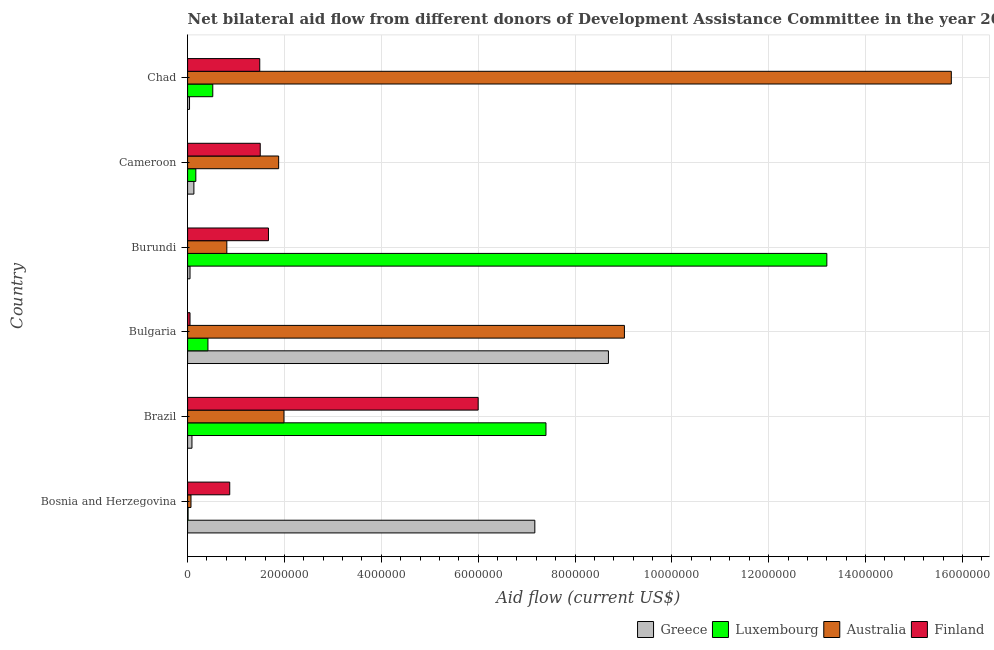How many different coloured bars are there?
Your answer should be very brief. 4. Are the number of bars per tick equal to the number of legend labels?
Offer a terse response. Yes. What is the label of the 3rd group of bars from the top?
Provide a short and direct response. Burundi. What is the amount of aid given by finland in Chad?
Provide a succinct answer. 1.49e+06. Across all countries, what is the maximum amount of aid given by australia?
Give a very brief answer. 1.58e+07. Across all countries, what is the minimum amount of aid given by australia?
Keep it short and to the point. 7.00e+04. In which country was the amount of aid given by australia maximum?
Your answer should be compact. Chad. In which country was the amount of aid given by luxembourg minimum?
Make the answer very short. Bosnia and Herzegovina. What is the total amount of aid given by finland in the graph?
Give a very brief answer. 1.16e+07. What is the difference between the amount of aid given by luxembourg in Bulgaria and that in Cameroon?
Offer a terse response. 2.50e+05. What is the difference between the amount of aid given by luxembourg in Bulgaria and the amount of aid given by australia in Bosnia and Herzegovina?
Your answer should be very brief. 3.50e+05. What is the average amount of aid given by greece per country?
Your response must be concise. 2.70e+06. What is the difference between the amount of aid given by finland and amount of aid given by australia in Cameroon?
Provide a succinct answer. -3.80e+05. In how many countries, is the amount of aid given by australia greater than 10400000 US$?
Offer a very short reply. 1. What is the ratio of the amount of aid given by luxembourg in Brazil to that in Chad?
Your answer should be compact. 14.23. Is the difference between the amount of aid given by australia in Bulgaria and Chad greater than the difference between the amount of aid given by luxembourg in Bulgaria and Chad?
Offer a very short reply. No. What is the difference between the highest and the second highest amount of aid given by greece?
Offer a very short reply. 1.52e+06. What is the difference between the highest and the lowest amount of aid given by finland?
Offer a terse response. 5.95e+06. In how many countries, is the amount of aid given by luxembourg greater than the average amount of aid given by luxembourg taken over all countries?
Ensure brevity in your answer.  2. Is it the case that in every country, the sum of the amount of aid given by australia and amount of aid given by luxembourg is greater than the sum of amount of aid given by finland and amount of aid given by greece?
Make the answer very short. No. What does the 2nd bar from the top in Burundi represents?
Offer a very short reply. Australia. Is it the case that in every country, the sum of the amount of aid given by greece and amount of aid given by luxembourg is greater than the amount of aid given by australia?
Your response must be concise. No. How many bars are there?
Keep it short and to the point. 24. Are all the bars in the graph horizontal?
Offer a very short reply. Yes. How many countries are there in the graph?
Ensure brevity in your answer.  6. Where does the legend appear in the graph?
Your answer should be compact. Bottom right. How many legend labels are there?
Your answer should be compact. 4. What is the title of the graph?
Give a very brief answer. Net bilateral aid flow from different donors of Development Assistance Committee in the year 2004. Does "Periodicity assessment" appear as one of the legend labels in the graph?
Give a very brief answer. No. What is the label or title of the X-axis?
Give a very brief answer. Aid flow (current US$). What is the label or title of the Y-axis?
Provide a succinct answer. Country. What is the Aid flow (current US$) in Greece in Bosnia and Herzegovina?
Your response must be concise. 7.17e+06. What is the Aid flow (current US$) of Luxembourg in Bosnia and Herzegovina?
Offer a very short reply. 10000. What is the Aid flow (current US$) of Finland in Bosnia and Herzegovina?
Your response must be concise. 8.70e+05. What is the Aid flow (current US$) in Greece in Brazil?
Provide a short and direct response. 9.00e+04. What is the Aid flow (current US$) in Luxembourg in Brazil?
Your answer should be very brief. 7.40e+06. What is the Aid flow (current US$) of Australia in Brazil?
Provide a succinct answer. 1.99e+06. What is the Aid flow (current US$) of Finland in Brazil?
Make the answer very short. 6.00e+06. What is the Aid flow (current US$) of Greece in Bulgaria?
Provide a succinct answer. 8.69e+06. What is the Aid flow (current US$) in Australia in Bulgaria?
Ensure brevity in your answer.  9.02e+06. What is the Aid flow (current US$) of Finland in Bulgaria?
Keep it short and to the point. 5.00e+04. What is the Aid flow (current US$) in Greece in Burundi?
Provide a short and direct response. 5.00e+04. What is the Aid flow (current US$) of Luxembourg in Burundi?
Offer a very short reply. 1.32e+07. What is the Aid flow (current US$) in Australia in Burundi?
Keep it short and to the point. 8.10e+05. What is the Aid flow (current US$) of Finland in Burundi?
Keep it short and to the point. 1.67e+06. What is the Aid flow (current US$) of Greece in Cameroon?
Keep it short and to the point. 1.30e+05. What is the Aid flow (current US$) of Australia in Cameroon?
Provide a short and direct response. 1.88e+06. What is the Aid flow (current US$) in Finland in Cameroon?
Provide a short and direct response. 1.50e+06. What is the Aid flow (current US$) in Greece in Chad?
Provide a short and direct response. 4.00e+04. What is the Aid flow (current US$) of Luxembourg in Chad?
Make the answer very short. 5.20e+05. What is the Aid flow (current US$) of Australia in Chad?
Make the answer very short. 1.58e+07. What is the Aid flow (current US$) in Finland in Chad?
Offer a terse response. 1.49e+06. Across all countries, what is the maximum Aid flow (current US$) in Greece?
Your response must be concise. 8.69e+06. Across all countries, what is the maximum Aid flow (current US$) in Luxembourg?
Ensure brevity in your answer.  1.32e+07. Across all countries, what is the maximum Aid flow (current US$) in Australia?
Keep it short and to the point. 1.58e+07. Across all countries, what is the maximum Aid flow (current US$) of Finland?
Keep it short and to the point. 6.00e+06. Across all countries, what is the minimum Aid flow (current US$) of Greece?
Offer a terse response. 4.00e+04. Across all countries, what is the minimum Aid flow (current US$) of Australia?
Make the answer very short. 7.00e+04. Across all countries, what is the minimum Aid flow (current US$) of Finland?
Provide a succinct answer. 5.00e+04. What is the total Aid flow (current US$) in Greece in the graph?
Provide a short and direct response. 1.62e+07. What is the total Aid flow (current US$) in Luxembourg in the graph?
Make the answer very short. 2.17e+07. What is the total Aid flow (current US$) in Australia in the graph?
Offer a terse response. 2.95e+07. What is the total Aid flow (current US$) in Finland in the graph?
Keep it short and to the point. 1.16e+07. What is the difference between the Aid flow (current US$) of Greece in Bosnia and Herzegovina and that in Brazil?
Offer a terse response. 7.08e+06. What is the difference between the Aid flow (current US$) in Luxembourg in Bosnia and Herzegovina and that in Brazil?
Offer a terse response. -7.39e+06. What is the difference between the Aid flow (current US$) of Australia in Bosnia and Herzegovina and that in Brazil?
Give a very brief answer. -1.92e+06. What is the difference between the Aid flow (current US$) of Finland in Bosnia and Herzegovina and that in Brazil?
Keep it short and to the point. -5.13e+06. What is the difference between the Aid flow (current US$) of Greece in Bosnia and Herzegovina and that in Bulgaria?
Your answer should be very brief. -1.52e+06. What is the difference between the Aid flow (current US$) of Luxembourg in Bosnia and Herzegovina and that in Bulgaria?
Offer a terse response. -4.10e+05. What is the difference between the Aid flow (current US$) of Australia in Bosnia and Herzegovina and that in Bulgaria?
Ensure brevity in your answer.  -8.95e+06. What is the difference between the Aid flow (current US$) in Finland in Bosnia and Herzegovina and that in Bulgaria?
Your answer should be compact. 8.20e+05. What is the difference between the Aid flow (current US$) of Greece in Bosnia and Herzegovina and that in Burundi?
Your answer should be very brief. 7.12e+06. What is the difference between the Aid flow (current US$) in Luxembourg in Bosnia and Herzegovina and that in Burundi?
Provide a short and direct response. -1.32e+07. What is the difference between the Aid flow (current US$) in Australia in Bosnia and Herzegovina and that in Burundi?
Your response must be concise. -7.40e+05. What is the difference between the Aid flow (current US$) of Finland in Bosnia and Herzegovina and that in Burundi?
Your answer should be very brief. -8.00e+05. What is the difference between the Aid flow (current US$) in Greece in Bosnia and Herzegovina and that in Cameroon?
Make the answer very short. 7.04e+06. What is the difference between the Aid flow (current US$) in Australia in Bosnia and Herzegovina and that in Cameroon?
Offer a very short reply. -1.81e+06. What is the difference between the Aid flow (current US$) of Finland in Bosnia and Herzegovina and that in Cameroon?
Ensure brevity in your answer.  -6.30e+05. What is the difference between the Aid flow (current US$) in Greece in Bosnia and Herzegovina and that in Chad?
Give a very brief answer. 7.13e+06. What is the difference between the Aid flow (current US$) in Luxembourg in Bosnia and Herzegovina and that in Chad?
Give a very brief answer. -5.10e+05. What is the difference between the Aid flow (current US$) in Australia in Bosnia and Herzegovina and that in Chad?
Give a very brief answer. -1.57e+07. What is the difference between the Aid flow (current US$) in Finland in Bosnia and Herzegovina and that in Chad?
Your response must be concise. -6.20e+05. What is the difference between the Aid flow (current US$) of Greece in Brazil and that in Bulgaria?
Provide a succinct answer. -8.60e+06. What is the difference between the Aid flow (current US$) in Luxembourg in Brazil and that in Bulgaria?
Give a very brief answer. 6.98e+06. What is the difference between the Aid flow (current US$) in Australia in Brazil and that in Bulgaria?
Your answer should be very brief. -7.03e+06. What is the difference between the Aid flow (current US$) in Finland in Brazil and that in Bulgaria?
Offer a very short reply. 5.95e+06. What is the difference between the Aid flow (current US$) of Luxembourg in Brazil and that in Burundi?
Keep it short and to the point. -5.80e+06. What is the difference between the Aid flow (current US$) in Australia in Brazil and that in Burundi?
Your answer should be compact. 1.18e+06. What is the difference between the Aid flow (current US$) in Finland in Brazil and that in Burundi?
Offer a terse response. 4.33e+06. What is the difference between the Aid flow (current US$) of Luxembourg in Brazil and that in Cameroon?
Provide a short and direct response. 7.23e+06. What is the difference between the Aid flow (current US$) of Finland in Brazil and that in Cameroon?
Make the answer very short. 4.50e+06. What is the difference between the Aid flow (current US$) of Greece in Brazil and that in Chad?
Give a very brief answer. 5.00e+04. What is the difference between the Aid flow (current US$) in Luxembourg in Brazil and that in Chad?
Provide a succinct answer. 6.88e+06. What is the difference between the Aid flow (current US$) in Australia in Brazil and that in Chad?
Provide a short and direct response. -1.38e+07. What is the difference between the Aid flow (current US$) of Finland in Brazil and that in Chad?
Your response must be concise. 4.51e+06. What is the difference between the Aid flow (current US$) in Greece in Bulgaria and that in Burundi?
Ensure brevity in your answer.  8.64e+06. What is the difference between the Aid flow (current US$) of Luxembourg in Bulgaria and that in Burundi?
Offer a terse response. -1.28e+07. What is the difference between the Aid flow (current US$) in Australia in Bulgaria and that in Burundi?
Give a very brief answer. 8.21e+06. What is the difference between the Aid flow (current US$) in Finland in Bulgaria and that in Burundi?
Your answer should be very brief. -1.62e+06. What is the difference between the Aid flow (current US$) in Greece in Bulgaria and that in Cameroon?
Your answer should be very brief. 8.56e+06. What is the difference between the Aid flow (current US$) in Australia in Bulgaria and that in Cameroon?
Offer a very short reply. 7.14e+06. What is the difference between the Aid flow (current US$) of Finland in Bulgaria and that in Cameroon?
Provide a short and direct response. -1.45e+06. What is the difference between the Aid flow (current US$) of Greece in Bulgaria and that in Chad?
Your answer should be compact. 8.65e+06. What is the difference between the Aid flow (current US$) of Luxembourg in Bulgaria and that in Chad?
Your response must be concise. -1.00e+05. What is the difference between the Aid flow (current US$) in Australia in Bulgaria and that in Chad?
Offer a terse response. -6.75e+06. What is the difference between the Aid flow (current US$) of Finland in Bulgaria and that in Chad?
Offer a very short reply. -1.44e+06. What is the difference between the Aid flow (current US$) in Luxembourg in Burundi and that in Cameroon?
Ensure brevity in your answer.  1.30e+07. What is the difference between the Aid flow (current US$) of Australia in Burundi and that in Cameroon?
Ensure brevity in your answer.  -1.07e+06. What is the difference between the Aid flow (current US$) of Greece in Burundi and that in Chad?
Your answer should be very brief. 10000. What is the difference between the Aid flow (current US$) of Luxembourg in Burundi and that in Chad?
Make the answer very short. 1.27e+07. What is the difference between the Aid flow (current US$) of Australia in Burundi and that in Chad?
Provide a short and direct response. -1.50e+07. What is the difference between the Aid flow (current US$) in Finland in Burundi and that in Chad?
Give a very brief answer. 1.80e+05. What is the difference between the Aid flow (current US$) in Greece in Cameroon and that in Chad?
Your response must be concise. 9.00e+04. What is the difference between the Aid flow (current US$) of Luxembourg in Cameroon and that in Chad?
Your answer should be compact. -3.50e+05. What is the difference between the Aid flow (current US$) of Australia in Cameroon and that in Chad?
Give a very brief answer. -1.39e+07. What is the difference between the Aid flow (current US$) in Greece in Bosnia and Herzegovina and the Aid flow (current US$) in Australia in Brazil?
Offer a very short reply. 5.18e+06. What is the difference between the Aid flow (current US$) in Greece in Bosnia and Herzegovina and the Aid flow (current US$) in Finland in Brazil?
Give a very brief answer. 1.17e+06. What is the difference between the Aid flow (current US$) in Luxembourg in Bosnia and Herzegovina and the Aid flow (current US$) in Australia in Brazil?
Your answer should be very brief. -1.98e+06. What is the difference between the Aid flow (current US$) of Luxembourg in Bosnia and Herzegovina and the Aid flow (current US$) of Finland in Brazil?
Keep it short and to the point. -5.99e+06. What is the difference between the Aid flow (current US$) of Australia in Bosnia and Herzegovina and the Aid flow (current US$) of Finland in Brazil?
Your answer should be very brief. -5.93e+06. What is the difference between the Aid flow (current US$) in Greece in Bosnia and Herzegovina and the Aid flow (current US$) in Luxembourg in Bulgaria?
Keep it short and to the point. 6.75e+06. What is the difference between the Aid flow (current US$) of Greece in Bosnia and Herzegovina and the Aid flow (current US$) of Australia in Bulgaria?
Provide a succinct answer. -1.85e+06. What is the difference between the Aid flow (current US$) of Greece in Bosnia and Herzegovina and the Aid flow (current US$) of Finland in Bulgaria?
Ensure brevity in your answer.  7.12e+06. What is the difference between the Aid flow (current US$) in Luxembourg in Bosnia and Herzegovina and the Aid flow (current US$) in Australia in Bulgaria?
Your response must be concise. -9.01e+06. What is the difference between the Aid flow (current US$) in Australia in Bosnia and Herzegovina and the Aid flow (current US$) in Finland in Bulgaria?
Provide a succinct answer. 2.00e+04. What is the difference between the Aid flow (current US$) of Greece in Bosnia and Herzegovina and the Aid flow (current US$) of Luxembourg in Burundi?
Provide a short and direct response. -6.03e+06. What is the difference between the Aid flow (current US$) in Greece in Bosnia and Herzegovina and the Aid flow (current US$) in Australia in Burundi?
Your response must be concise. 6.36e+06. What is the difference between the Aid flow (current US$) of Greece in Bosnia and Herzegovina and the Aid flow (current US$) of Finland in Burundi?
Keep it short and to the point. 5.50e+06. What is the difference between the Aid flow (current US$) of Luxembourg in Bosnia and Herzegovina and the Aid flow (current US$) of Australia in Burundi?
Make the answer very short. -8.00e+05. What is the difference between the Aid flow (current US$) in Luxembourg in Bosnia and Herzegovina and the Aid flow (current US$) in Finland in Burundi?
Your answer should be compact. -1.66e+06. What is the difference between the Aid flow (current US$) in Australia in Bosnia and Herzegovina and the Aid flow (current US$) in Finland in Burundi?
Your answer should be compact. -1.60e+06. What is the difference between the Aid flow (current US$) of Greece in Bosnia and Herzegovina and the Aid flow (current US$) of Luxembourg in Cameroon?
Provide a succinct answer. 7.00e+06. What is the difference between the Aid flow (current US$) of Greece in Bosnia and Herzegovina and the Aid flow (current US$) of Australia in Cameroon?
Offer a terse response. 5.29e+06. What is the difference between the Aid flow (current US$) of Greece in Bosnia and Herzegovina and the Aid flow (current US$) of Finland in Cameroon?
Offer a terse response. 5.67e+06. What is the difference between the Aid flow (current US$) in Luxembourg in Bosnia and Herzegovina and the Aid flow (current US$) in Australia in Cameroon?
Give a very brief answer. -1.87e+06. What is the difference between the Aid flow (current US$) in Luxembourg in Bosnia and Herzegovina and the Aid flow (current US$) in Finland in Cameroon?
Your response must be concise. -1.49e+06. What is the difference between the Aid flow (current US$) of Australia in Bosnia and Herzegovina and the Aid flow (current US$) of Finland in Cameroon?
Offer a terse response. -1.43e+06. What is the difference between the Aid flow (current US$) in Greece in Bosnia and Herzegovina and the Aid flow (current US$) in Luxembourg in Chad?
Provide a succinct answer. 6.65e+06. What is the difference between the Aid flow (current US$) in Greece in Bosnia and Herzegovina and the Aid flow (current US$) in Australia in Chad?
Offer a very short reply. -8.60e+06. What is the difference between the Aid flow (current US$) of Greece in Bosnia and Herzegovina and the Aid flow (current US$) of Finland in Chad?
Your answer should be very brief. 5.68e+06. What is the difference between the Aid flow (current US$) of Luxembourg in Bosnia and Herzegovina and the Aid flow (current US$) of Australia in Chad?
Offer a terse response. -1.58e+07. What is the difference between the Aid flow (current US$) in Luxembourg in Bosnia and Herzegovina and the Aid flow (current US$) in Finland in Chad?
Your answer should be very brief. -1.48e+06. What is the difference between the Aid flow (current US$) of Australia in Bosnia and Herzegovina and the Aid flow (current US$) of Finland in Chad?
Your response must be concise. -1.42e+06. What is the difference between the Aid flow (current US$) of Greece in Brazil and the Aid flow (current US$) of Luxembourg in Bulgaria?
Offer a very short reply. -3.30e+05. What is the difference between the Aid flow (current US$) of Greece in Brazil and the Aid flow (current US$) of Australia in Bulgaria?
Offer a very short reply. -8.93e+06. What is the difference between the Aid flow (current US$) in Greece in Brazil and the Aid flow (current US$) in Finland in Bulgaria?
Your response must be concise. 4.00e+04. What is the difference between the Aid flow (current US$) in Luxembourg in Brazil and the Aid flow (current US$) in Australia in Bulgaria?
Give a very brief answer. -1.62e+06. What is the difference between the Aid flow (current US$) of Luxembourg in Brazil and the Aid flow (current US$) of Finland in Bulgaria?
Ensure brevity in your answer.  7.35e+06. What is the difference between the Aid flow (current US$) in Australia in Brazil and the Aid flow (current US$) in Finland in Bulgaria?
Offer a very short reply. 1.94e+06. What is the difference between the Aid flow (current US$) in Greece in Brazil and the Aid flow (current US$) in Luxembourg in Burundi?
Provide a succinct answer. -1.31e+07. What is the difference between the Aid flow (current US$) of Greece in Brazil and the Aid flow (current US$) of Australia in Burundi?
Keep it short and to the point. -7.20e+05. What is the difference between the Aid flow (current US$) of Greece in Brazil and the Aid flow (current US$) of Finland in Burundi?
Keep it short and to the point. -1.58e+06. What is the difference between the Aid flow (current US$) in Luxembourg in Brazil and the Aid flow (current US$) in Australia in Burundi?
Make the answer very short. 6.59e+06. What is the difference between the Aid flow (current US$) of Luxembourg in Brazil and the Aid flow (current US$) of Finland in Burundi?
Ensure brevity in your answer.  5.73e+06. What is the difference between the Aid flow (current US$) in Australia in Brazil and the Aid flow (current US$) in Finland in Burundi?
Your answer should be very brief. 3.20e+05. What is the difference between the Aid flow (current US$) of Greece in Brazil and the Aid flow (current US$) of Australia in Cameroon?
Offer a terse response. -1.79e+06. What is the difference between the Aid flow (current US$) in Greece in Brazil and the Aid flow (current US$) in Finland in Cameroon?
Your answer should be compact. -1.41e+06. What is the difference between the Aid flow (current US$) of Luxembourg in Brazil and the Aid flow (current US$) of Australia in Cameroon?
Ensure brevity in your answer.  5.52e+06. What is the difference between the Aid flow (current US$) in Luxembourg in Brazil and the Aid flow (current US$) in Finland in Cameroon?
Ensure brevity in your answer.  5.90e+06. What is the difference between the Aid flow (current US$) of Greece in Brazil and the Aid flow (current US$) of Luxembourg in Chad?
Provide a short and direct response. -4.30e+05. What is the difference between the Aid flow (current US$) in Greece in Brazil and the Aid flow (current US$) in Australia in Chad?
Offer a very short reply. -1.57e+07. What is the difference between the Aid flow (current US$) of Greece in Brazil and the Aid flow (current US$) of Finland in Chad?
Provide a succinct answer. -1.40e+06. What is the difference between the Aid flow (current US$) in Luxembourg in Brazil and the Aid flow (current US$) in Australia in Chad?
Keep it short and to the point. -8.37e+06. What is the difference between the Aid flow (current US$) in Luxembourg in Brazil and the Aid flow (current US$) in Finland in Chad?
Offer a terse response. 5.91e+06. What is the difference between the Aid flow (current US$) in Greece in Bulgaria and the Aid flow (current US$) in Luxembourg in Burundi?
Your answer should be compact. -4.51e+06. What is the difference between the Aid flow (current US$) of Greece in Bulgaria and the Aid flow (current US$) of Australia in Burundi?
Your answer should be very brief. 7.88e+06. What is the difference between the Aid flow (current US$) of Greece in Bulgaria and the Aid flow (current US$) of Finland in Burundi?
Your answer should be very brief. 7.02e+06. What is the difference between the Aid flow (current US$) of Luxembourg in Bulgaria and the Aid flow (current US$) of Australia in Burundi?
Ensure brevity in your answer.  -3.90e+05. What is the difference between the Aid flow (current US$) in Luxembourg in Bulgaria and the Aid flow (current US$) in Finland in Burundi?
Your answer should be compact. -1.25e+06. What is the difference between the Aid flow (current US$) in Australia in Bulgaria and the Aid flow (current US$) in Finland in Burundi?
Your response must be concise. 7.35e+06. What is the difference between the Aid flow (current US$) of Greece in Bulgaria and the Aid flow (current US$) of Luxembourg in Cameroon?
Your response must be concise. 8.52e+06. What is the difference between the Aid flow (current US$) in Greece in Bulgaria and the Aid flow (current US$) in Australia in Cameroon?
Keep it short and to the point. 6.81e+06. What is the difference between the Aid flow (current US$) in Greece in Bulgaria and the Aid flow (current US$) in Finland in Cameroon?
Provide a short and direct response. 7.19e+06. What is the difference between the Aid flow (current US$) of Luxembourg in Bulgaria and the Aid flow (current US$) of Australia in Cameroon?
Your answer should be compact. -1.46e+06. What is the difference between the Aid flow (current US$) in Luxembourg in Bulgaria and the Aid flow (current US$) in Finland in Cameroon?
Make the answer very short. -1.08e+06. What is the difference between the Aid flow (current US$) of Australia in Bulgaria and the Aid flow (current US$) of Finland in Cameroon?
Provide a short and direct response. 7.52e+06. What is the difference between the Aid flow (current US$) in Greece in Bulgaria and the Aid flow (current US$) in Luxembourg in Chad?
Give a very brief answer. 8.17e+06. What is the difference between the Aid flow (current US$) of Greece in Bulgaria and the Aid flow (current US$) of Australia in Chad?
Make the answer very short. -7.08e+06. What is the difference between the Aid flow (current US$) in Greece in Bulgaria and the Aid flow (current US$) in Finland in Chad?
Make the answer very short. 7.20e+06. What is the difference between the Aid flow (current US$) in Luxembourg in Bulgaria and the Aid flow (current US$) in Australia in Chad?
Offer a terse response. -1.54e+07. What is the difference between the Aid flow (current US$) of Luxembourg in Bulgaria and the Aid flow (current US$) of Finland in Chad?
Give a very brief answer. -1.07e+06. What is the difference between the Aid flow (current US$) of Australia in Bulgaria and the Aid flow (current US$) of Finland in Chad?
Keep it short and to the point. 7.53e+06. What is the difference between the Aid flow (current US$) in Greece in Burundi and the Aid flow (current US$) in Luxembourg in Cameroon?
Make the answer very short. -1.20e+05. What is the difference between the Aid flow (current US$) in Greece in Burundi and the Aid flow (current US$) in Australia in Cameroon?
Offer a terse response. -1.83e+06. What is the difference between the Aid flow (current US$) in Greece in Burundi and the Aid flow (current US$) in Finland in Cameroon?
Give a very brief answer. -1.45e+06. What is the difference between the Aid flow (current US$) of Luxembourg in Burundi and the Aid flow (current US$) of Australia in Cameroon?
Offer a very short reply. 1.13e+07. What is the difference between the Aid flow (current US$) of Luxembourg in Burundi and the Aid flow (current US$) of Finland in Cameroon?
Ensure brevity in your answer.  1.17e+07. What is the difference between the Aid flow (current US$) of Australia in Burundi and the Aid flow (current US$) of Finland in Cameroon?
Offer a very short reply. -6.90e+05. What is the difference between the Aid flow (current US$) of Greece in Burundi and the Aid flow (current US$) of Luxembourg in Chad?
Your response must be concise. -4.70e+05. What is the difference between the Aid flow (current US$) in Greece in Burundi and the Aid flow (current US$) in Australia in Chad?
Give a very brief answer. -1.57e+07. What is the difference between the Aid flow (current US$) in Greece in Burundi and the Aid flow (current US$) in Finland in Chad?
Ensure brevity in your answer.  -1.44e+06. What is the difference between the Aid flow (current US$) of Luxembourg in Burundi and the Aid flow (current US$) of Australia in Chad?
Give a very brief answer. -2.57e+06. What is the difference between the Aid flow (current US$) in Luxembourg in Burundi and the Aid flow (current US$) in Finland in Chad?
Provide a short and direct response. 1.17e+07. What is the difference between the Aid flow (current US$) in Australia in Burundi and the Aid flow (current US$) in Finland in Chad?
Your answer should be very brief. -6.80e+05. What is the difference between the Aid flow (current US$) of Greece in Cameroon and the Aid flow (current US$) of Luxembourg in Chad?
Your response must be concise. -3.90e+05. What is the difference between the Aid flow (current US$) in Greece in Cameroon and the Aid flow (current US$) in Australia in Chad?
Your answer should be very brief. -1.56e+07. What is the difference between the Aid flow (current US$) of Greece in Cameroon and the Aid flow (current US$) of Finland in Chad?
Give a very brief answer. -1.36e+06. What is the difference between the Aid flow (current US$) in Luxembourg in Cameroon and the Aid flow (current US$) in Australia in Chad?
Provide a short and direct response. -1.56e+07. What is the difference between the Aid flow (current US$) in Luxembourg in Cameroon and the Aid flow (current US$) in Finland in Chad?
Give a very brief answer. -1.32e+06. What is the difference between the Aid flow (current US$) of Australia in Cameroon and the Aid flow (current US$) of Finland in Chad?
Keep it short and to the point. 3.90e+05. What is the average Aid flow (current US$) in Greece per country?
Provide a succinct answer. 2.70e+06. What is the average Aid flow (current US$) in Luxembourg per country?
Offer a terse response. 3.62e+06. What is the average Aid flow (current US$) in Australia per country?
Give a very brief answer. 4.92e+06. What is the average Aid flow (current US$) in Finland per country?
Your response must be concise. 1.93e+06. What is the difference between the Aid flow (current US$) in Greece and Aid flow (current US$) in Luxembourg in Bosnia and Herzegovina?
Keep it short and to the point. 7.16e+06. What is the difference between the Aid flow (current US$) of Greece and Aid flow (current US$) of Australia in Bosnia and Herzegovina?
Offer a very short reply. 7.10e+06. What is the difference between the Aid flow (current US$) in Greece and Aid flow (current US$) in Finland in Bosnia and Herzegovina?
Your response must be concise. 6.30e+06. What is the difference between the Aid flow (current US$) of Luxembourg and Aid flow (current US$) of Australia in Bosnia and Herzegovina?
Offer a very short reply. -6.00e+04. What is the difference between the Aid flow (current US$) in Luxembourg and Aid flow (current US$) in Finland in Bosnia and Herzegovina?
Provide a succinct answer. -8.60e+05. What is the difference between the Aid flow (current US$) in Australia and Aid flow (current US$) in Finland in Bosnia and Herzegovina?
Give a very brief answer. -8.00e+05. What is the difference between the Aid flow (current US$) in Greece and Aid flow (current US$) in Luxembourg in Brazil?
Offer a very short reply. -7.31e+06. What is the difference between the Aid flow (current US$) of Greece and Aid flow (current US$) of Australia in Brazil?
Your answer should be compact. -1.90e+06. What is the difference between the Aid flow (current US$) in Greece and Aid flow (current US$) in Finland in Brazil?
Keep it short and to the point. -5.91e+06. What is the difference between the Aid flow (current US$) of Luxembourg and Aid flow (current US$) of Australia in Brazil?
Your answer should be compact. 5.41e+06. What is the difference between the Aid flow (current US$) of Luxembourg and Aid flow (current US$) of Finland in Brazil?
Your answer should be compact. 1.40e+06. What is the difference between the Aid flow (current US$) of Australia and Aid flow (current US$) of Finland in Brazil?
Keep it short and to the point. -4.01e+06. What is the difference between the Aid flow (current US$) in Greece and Aid flow (current US$) in Luxembourg in Bulgaria?
Offer a very short reply. 8.27e+06. What is the difference between the Aid flow (current US$) of Greece and Aid flow (current US$) of Australia in Bulgaria?
Your response must be concise. -3.30e+05. What is the difference between the Aid flow (current US$) of Greece and Aid flow (current US$) of Finland in Bulgaria?
Provide a short and direct response. 8.64e+06. What is the difference between the Aid flow (current US$) of Luxembourg and Aid flow (current US$) of Australia in Bulgaria?
Provide a short and direct response. -8.60e+06. What is the difference between the Aid flow (current US$) in Luxembourg and Aid flow (current US$) in Finland in Bulgaria?
Your answer should be compact. 3.70e+05. What is the difference between the Aid flow (current US$) of Australia and Aid flow (current US$) of Finland in Bulgaria?
Your answer should be very brief. 8.97e+06. What is the difference between the Aid flow (current US$) of Greece and Aid flow (current US$) of Luxembourg in Burundi?
Make the answer very short. -1.32e+07. What is the difference between the Aid flow (current US$) of Greece and Aid flow (current US$) of Australia in Burundi?
Offer a very short reply. -7.60e+05. What is the difference between the Aid flow (current US$) in Greece and Aid flow (current US$) in Finland in Burundi?
Offer a terse response. -1.62e+06. What is the difference between the Aid flow (current US$) of Luxembourg and Aid flow (current US$) of Australia in Burundi?
Offer a terse response. 1.24e+07. What is the difference between the Aid flow (current US$) in Luxembourg and Aid flow (current US$) in Finland in Burundi?
Offer a very short reply. 1.15e+07. What is the difference between the Aid flow (current US$) in Australia and Aid flow (current US$) in Finland in Burundi?
Make the answer very short. -8.60e+05. What is the difference between the Aid flow (current US$) of Greece and Aid flow (current US$) of Luxembourg in Cameroon?
Provide a succinct answer. -4.00e+04. What is the difference between the Aid flow (current US$) in Greece and Aid flow (current US$) in Australia in Cameroon?
Your answer should be compact. -1.75e+06. What is the difference between the Aid flow (current US$) in Greece and Aid flow (current US$) in Finland in Cameroon?
Provide a short and direct response. -1.37e+06. What is the difference between the Aid flow (current US$) in Luxembourg and Aid flow (current US$) in Australia in Cameroon?
Offer a very short reply. -1.71e+06. What is the difference between the Aid flow (current US$) in Luxembourg and Aid flow (current US$) in Finland in Cameroon?
Provide a succinct answer. -1.33e+06. What is the difference between the Aid flow (current US$) of Greece and Aid flow (current US$) of Luxembourg in Chad?
Offer a terse response. -4.80e+05. What is the difference between the Aid flow (current US$) of Greece and Aid flow (current US$) of Australia in Chad?
Your answer should be compact. -1.57e+07. What is the difference between the Aid flow (current US$) of Greece and Aid flow (current US$) of Finland in Chad?
Provide a succinct answer. -1.45e+06. What is the difference between the Aid flow (current US$) in Luxembourg and Aid flow (current US$) in Australia in Chad?
Offer a very short reply. -1.52e+07. What is the difference between the Aid flow (current US$) of Luxembourg and Aid flow (current US$) of Finland in Chad?
Ensure brevity in your answer.  -9.70e+05. What is the difference between the Aid flow (current US$) of Australia and Aid flow (current US$) of Finland in Chad?
Your response must be concise. 1.43e+07. What is the ratio of the Aid flow (current US$) of Greece in Bosnia and Herzegovina to that in Brazil?
Ensure brevity in your answer.  79.67. What is the ratio of the Aid flow (current US$) of Luxembourg in Bosnia and Herzegovina to that in Brazil?
Give a very brief answer. 0. What is the ratio of the Aid flow (current US$) in Australia in Bosnia and Herzegovina to that in Brazil?
Make the answer very short. 0.04. What is the ratio of the Aid flow (current US$) in Finland in Bosnia and Herzegovina to that in Brazil?
Offer a very short reply. 0.14. What is the ratio of the Aid flow (current US$) of Greece in Bosnia and Herzegovina to that in Bulgaria?
Give a very brief answer. 0.83. What is the ratio of the Aid flow (current US$) of Luxembourg in Bosnia and Herzegovina to that in Bulgaria?
Make the answer very short. 0.02. What is the ratio of the Aid flow (current US$) in Australia in Bosnia and Herzegovina to that in Bulgaria?
Provide a short and direct response. 0.01. What is the ratio of the Aid flow (current US$) in Finland in Bosnia and Herzegovina to that in Bulgaria?
Offer a very short reply. 17.4. What is the ratio of the Aid flow (current US$) of Greece in Bosnia and Herzegovina to that in Burundi?
Offer a very short reply. 143.4. What is the ratio of the Aid flow (current US$) in Luxembourg in Bosnia and Herzegovina to that in Burundi?
Ensure brevity in your answer.  0. What is the ratio of the Aid flow (current US$) in Australia in Bosnia and Herzegovina to that in Burundi?
Offer a very short reply. 0.09. What is the ratio of the Aid flow (current US$) of Finland in Bosnia and Herzegovina to that in Burundi?
Ensure brevity in your answer.  0.52. What is the ratio of the Aid flow (current US$) in Greece in Bosnia and Herzegovina to that in Cameroon?
Make the answer very short. 55.15. What is the ratio of the Aid flow (current US$) of Luxembourg in Bosnia and Herzegovina to that in Cameroon?
Ensure brevity in your answer.  0.06. What is the ratio of the Aid flow (current US$) in Australia in Bosnia and Herzegovina to that in Cameroon?
Your answer should be compact. 0.04. What is the ratio of the Aid flow (current US$) of Finland in Bosnia and Herzegovina to that in Cameroon?
Provide a succinct answer. 0.58. What is the ratio of the Aid flow (current US$) of Greece in Bosnia and Herzegovina to that in Chad?
Give a very brief answer. 179.25. What is the ratio of the Aid flow (current US$) of Luxembourg in Bosnia and Herzegovina to that in Chad?
Offer a terse response. 0.02. What is the ratio of the Aid flow (current US$) of Australia in Bosnia and Herzegovina to that in Chad?
Ensure brevity in your answer.  0. What is the ratio of the Aid flow (current US$) in Finland in Bosnia and Herzegovina to that in Chad?
Make the answer very short. 0.58. What is the ratio of the Aid flow (current US$) in Greece in Brazil to that in Bulgaria?
Give a very brief answer. 0.01. What is the ratio of the Aid flow (current US$) of Luxembourg in Brazil to that in Bulgaria?
Your answer should be very brief. 17.62. What is the ratio of the Aid flow (current US$) of Australia in Brazil to that in Bulgaria?
Provide a succinct answer. 0.22. What is the ratio of the Aid flow (current US$) in Finland in Brazil to that in Bulgaria?
Make the answer very short. 120. What is the ratio of the Aid flow (current US$) of Greece in Brazil to that in Burundi?
Your response must be concise. 1.8. What is the ratio of the Aid flow (current US$) of Luxembourg in Brazil to that in Burundi?
Offer a very short reply. 0.56. What is the ratio of the Aid flow (current US$) of Australia in Brazil to that in Burundi?
Provide a succinct answer. 2.46. What is the ratio of the Aid flow (current US$) in Finland in Brazil to that in Burundi?
Your answer should be compact. 3.59. What is the ratio of the Aid flow (current US$) in Greece in Brazil to that in Cameroon?
Your answer should be very brief. 0.69. What is the ratio of the Aid flow (current US$) in Luxembourg in Brazil to that in Cameroon?
Your answer should be very brief. 43.53. What is the ratio of the Aid flow (current US$) of Australia in Brazil to that in Cameroon?
Make the answer very short. 1.06. What is the ratio of the Aid flow (current US$) in Greece in Brazil to that in Chad?
Provide a succinct answer. 2.25. What is the ratio of the Aid flow (current US$) of Luxembourg in Brazil to that in Chad?
Your answer should be compact. 14.23. What is the ratio of the Aid flow (current US$) in Australia in Brazil to that in Chad?
Provide a short and direct response. 0.13. What is the ratio of the Aid flow (current US$) of Finland in Brazil to that in Chad?
Make the answer very short. 4.03. What is the ratio of the Aid flow (current US$) in Greece in Bulgaria to that in Burundi?
Keep it short and to the point. 173.8. What is the ratio of the Aid flow (current US$) in Luxembourg in Bulgaria to that in Burundi?
Give a very brief answer. 0.03. What is the ratio of the Aid flow (current US$) in Australia in Bulgaria to that in Burundi?
Offer a terse response. 11.14. What is the ratio of the Aid flow (current US$) of Finland in Bulgaria to that in Burundi?
Provide a succinct answer. 0.03. What is the ratio of the Aid flow (current US$) of Greece in Bulgaria to that in Cameroon?
Provide a succinct answer. 66.85. What is the ratio of the Aid flow (current US$) of Luxembourg in Bulgaria to that in Cameroon?
Provide a short and direct response. 2.47. What is the ratio of the Aid flow (current US$) of Australia in Bulgaria to that in Cameroon?
Make the answer very short. 4.8. What is the ratio of the Aid flow (current US$) in Greece in Bulgaria to that in Chad?
Provide a short and direct response. 217.25. What is the ratio of the Aid flow (current US$) of Luxembourg in Bulgaria to that in Chad?
Provide a succinct answer. 0.81. What is the ratio of the Aid flow (current US$) in Australia in Bulgaria to that in Chad?
Keep it short and to the point. 0.57. What is the ratio of the Aid flow (current US$) of Finland in Bulgaria to that in Chad?
Offer a terse response. 0.03. What is the ratio of the Aid flow (current US$) of Greece in Burundi to that in Cameroon?
Offer a very short reply. 0.38. What is the ratio of the Aid flow (current US$) of Luxembourg in Burundi to that in Cameroon?
Make the answer very short. 77.65. What is the ratio of the Aid flow (current US$) in Australia in Burundi to that in Cameroon?
Offer a very short reply. 0.43. What is the ratio of the Aid flow (current US$) in Finland in Burundi to that in Cameroon?
Offer a very short reply. 1.11. What is the ratio of the Aid flow (current US$) in Greece in Burundi to that in Chad?
Ensure brevity in your answer.  1.25. What is the ratio of the Aid flow (current US$) in Luxembourg in Burundi to that in Chad?
Make the answer very short. 25.38. What is the ratio of the Aid flow (current US$) of Australia in Burundi to that in Chad?
Keep it short and to the point. 0.05. What is the ratio of the Aid flow (current US$) in Finland in Burundi to that in Chad?
Provide a succinct answer. 1.12. What is the ratio of the Aid flow (current US$) in Greece in Cameroon to that in Chad?
Provide a short and direct response. 3.25. What is the ratio of the Aid flow (current US$) of Luxembourg in Cameroon to that in Chad?
Ensure brevity in your answer.  0.33. What is the ratio of the Aid flow (current US$) in Australia in Cameroon to that in Chad?
Give a very brief answer. 0.12. What is the difference between the highest and the second highest Aid flow (current US$) in Greece?
Make the answer very short. 1.52e+06. What is the difference between the highest and the second highest Aid flow (current US$) in Luxembourg?
Make the answer very short. 5.80e+06. What is the difference between the highest and the second highest Aid flow (current US$) of Australia?
Your response must be concise. 6.75e+06. What is the difference between the highest and the second highest Aid flow (current US$) in Finland?
Provide a succinct answer. 4.33e+06. What is the difference between the highest and the lowest Aid flow (current US$) in Greece?
Your answer should be very brief. 8.65e+06. What is the difference between the highest and the lowest Aid flow (current US$) of Luxembourg?
Make the answer very short. 1.32e+07. What is the difference between the highest and the lowest Aid flow (current US$) in Australia?
Give a very brief answer. 1.57e+07. What is the difference between the highest and the lowest Aid flow (current US$) in Finland?
Offer a terse response. 5.95e+06. 